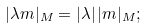<formula> <loc_0><loc_0><loc_500><loc_500>| \lambda m | _ { M } = | \lambda | \, | m | _ { M } ;</formula> 